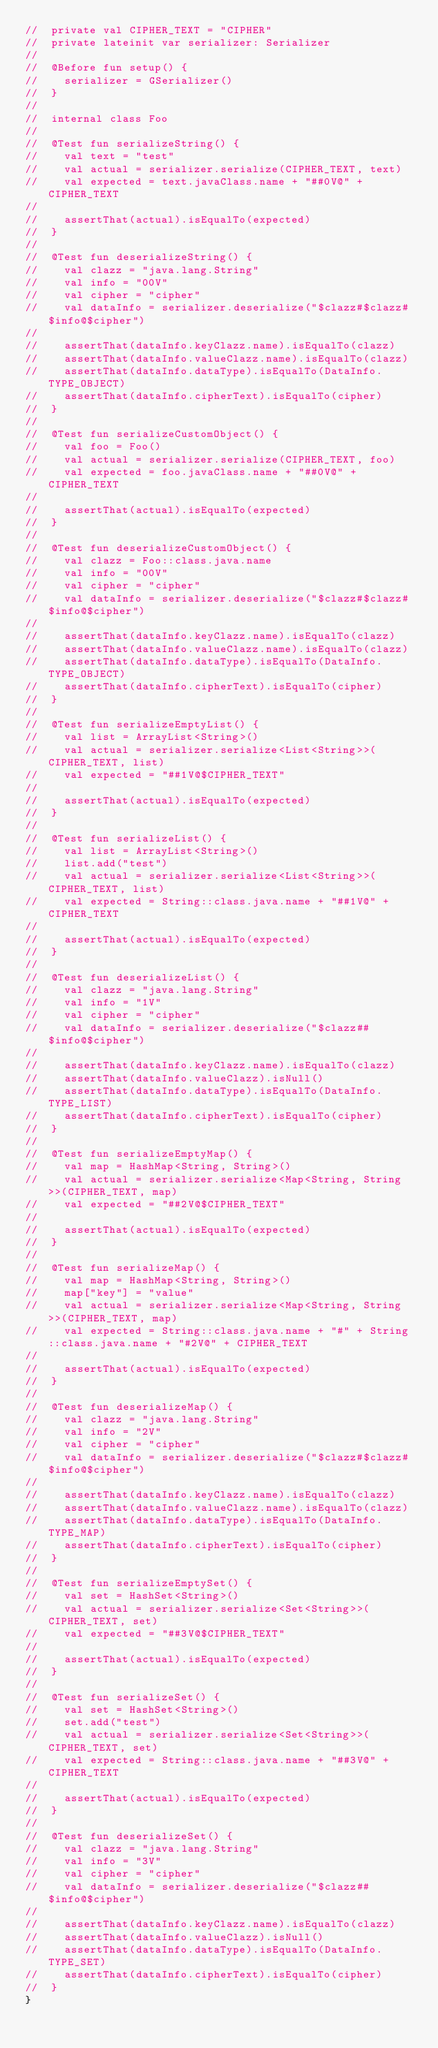Convert code to text. <code><loc_0><loc_0><loc_500><loc_500><_Kotlin_>//  private val CIPHER_TEXT = "CIPHER"
//  private lateinit var serializer: Serializer
//
//  @Before fun setup() {
//    serializer = GSerializer()
//  }
//
//  internal class Foo
//
//  @Test fun serializeString() {
//    val text = "test"
//    val actual = serializer.serialize(CIPHER_TEXT, text)
//    val expected = text.javaClass.name + "##0V@" + CIPHER_TEXT
//
//    assertThat(actual).isEqualTo(expected)
//  }
//
//  @Test fun deserializeString() {
//    val clazz = "java.lang.String"
//    val info = "00V"
//    val cipher = "cipher"
//    val dataInfo = serializer.deserialize("$clazz#$clazz#$info@$cipher")
//
//    assertThat(dataInfo.keyClazz.name).isEqualTo(clazz)
//    assertThat(dataInfo.valueClazz.name).isEqualTo(clazz)
//    assertThat(dataInfo.dataType).isEqualTo(DataInfo.TYPE_OBJECT)
//    assertThat(dataInfo.cipherText).isEqualTo(cipher)
//  }
//
//  @Test fun serializeCustomObject() {
//    val foo = Foo()
//    val actual = serializer.serialize(CIPHER_TEXT, foo)
//    val expected = foo.javaClass.name + "##0V@" + CIPHER_TEXT
//
//    assertThat(actual).isEqualTo(expected)
//  }
//
//  @Test fun deserializeCustomObject() {
//    val clazz = Foo::class.java.name
//    val info = "00V"
//    val cipher = "cipher"
//    val dataInfo = serializer.deserialize("$clazz#$clazz#$info@$cipher")
//
//    assertThat(dataInfo.keyClazz.name).isEqualTo(clazz)
//    assertThat(dataInfo.valueClazz.name).isEqualTo(clazz)
//    assertThat(dataInfo.dataType).isEqualTo(DataInfo.TYPE_OBJECT)
//    assertThat(dataInfo.cipherText).isEqualTo(cipher)
//  }
//
//  @Test fun serializeEmptyList() {
//    val list = ArrayList<String>()
//    val actual = serializer.serialize<List<String>>(CIPHER_TEXT, list)
//    val expected = "##1V@$CIPHER_TEXT"
//
//    assertThat(actual).isEqualTo(expected)
//  }
//
//  @Test fun serializeList() {
//    val list = ArrayList<String>()
//    list.add("test")
//    val actual = serializer.serialize<List<String>>(CIPHER_TEXT, list)
//    val expected = String::class.java.name + "##1V@" + CIPHER_TEXT
//
//    assertThat(actual).isEqualTo(expected)
//  }
//
//  @Test fun deserializeList() {
//    val clazz = "java.lang.String"
//    val info = "1V"
//    val cipher = "cipher"
//    val dataInfo = serializer.deserialize("$clazz##$info@$cipher")
//
//    assertThat(dataInfo.keyClazz.name).isEqualTo(clazz)
//    assertThat(dataInfo.valueClazz).isNull()
//    assertThat(dataInfo.dataType).isEqualTo(DataInfo.TYPE_LIST)
//    assertThat(dataInfo.cipherText).isEqualTo(cipher)
//  }
//
//  @Test fun serializeEmptyMap() {
//    val map = HashMap<String, String>()
//    val actual = serializer.serialize<Map<String, String>>(CIPHER_TEXT, map)
//    val expected = "##2V@$CIPHER_TEXT"
//
//    assertThat(actual).isEqualTo(expected)
//  }
//
//  @Test fun serializeMap() {
//    val map = HashMap<String, String>()
//    map["key"] = "value"
//    val actual = serializer.serialize<Map<String, String>>(CIPHER_TEXT, map)
//    val expected = String::class.java.name + "#" + String::class.java.name + "#2V@" + CIPHER_TEXT
//
//    assertThat(actual).isEqualTo(expected)
//  }
//
//  @Test fun deserializeMap() {
//    val clazz = "java.lang.String"
//    val info = "2V"
//    val cipher = "cipher"
//    val dataInfo = serializer.deserialize("$clazz#$clazz#$info@$cipher")
//
//    assertThat(dataInfo.keyClazz.name).isEqualTo(clazz)
//    assertThat(dataInfo.valueClazz.name).isEqualTo(clazz)
//    assertThat(dataInfo.dataType).isEqualTo(DataInfo.TYPE_MAP)
//    assertThat(dataInfo.cipherText).isEqualTo(cipher)
//  }
//
//  @Test fun serializeEmptySet() {
//    val set = HashSet<String>()
//    val actual = serializer.serialize<Set<String>>(CIPHER_TEXT, set)
//    val expected = "##3V@$CIPHER_TEXT"
//
//    assertThat(actual).isEqualTo(expected)
//  }
//
//  @Test fun serializeSet() {
//    val set = HashSet<String>()
//    set.add("test")
//    val actual = serializer.serialize<Set<String>>(CIPHER_TEXT, set)
//    val expected = String::class.java.name + "##3V@" + CIPHER_TEXT
//
//    assertThat(actual).isEqualTo(expected)
//  }
//
//  @Test fun deserializeSet() {
//    val clazz = "java.lang.String"
//    val info = "3V"
//    val cipher = "cipher"
//    val dataInfo = serializer.deserialize("$clazz##$info@$cipher")
//
//    assertThat(dataInfo.keyClazz.name).isEqualTo(clazz)
//    assertThat(dataInfo.valueClazz).isNull()
//    assertThat(dataInfo.dataType).isEqualTo(DataInfo.TYPE_SET)
//    assertThat(dataInfo.cipherText).isEqualTo(cipher)
//  }
}</code> 